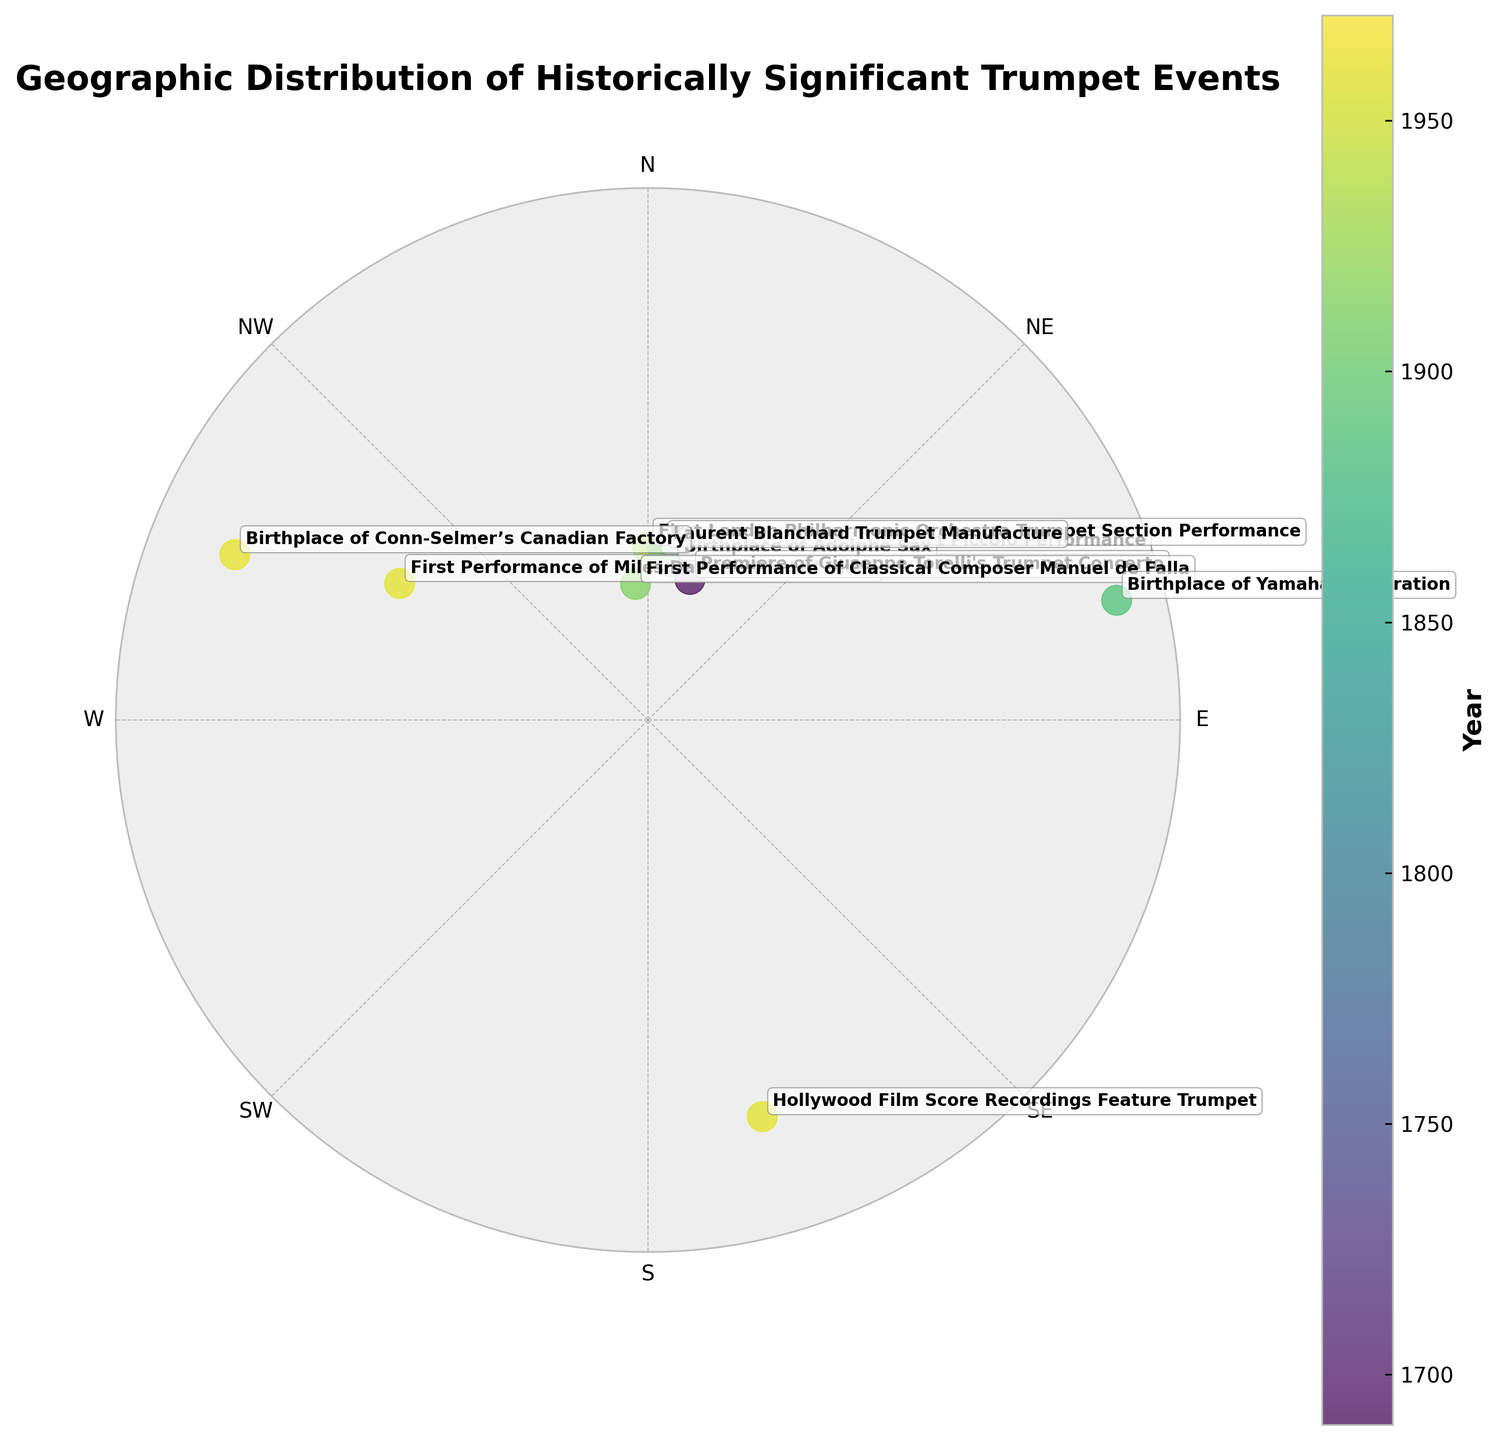what is the title of the graph? The title is located at the top of the graph and provides an overview of what the graph depicts. It reads, "Geographic Distribution of Historically Significant Trumpet Events."
Answer: Geographic Distribution of Historically Significant Trumpet Events What does the color of the scatter points represent? The color of the scatter points is based on a color bar that appears to the right of the chart and is labeled "Year," indicating that colors represent the years of the events or birthplaces.
Answer: Year How many significant data points are plotted on the graph? Each data point corresponds to an event or birthplace indicated in the graph. By counting the number of annotated points, we find there are 10 plotted data points.
Answer: 10 Which event is represented by the farthest scatter point from the center? The distance of each scatter point from the center of a polar chart corresponds to the radial component 'r'. The farthest scatter point is labeled as the "First Performance of Miles Davis's 'Kind of Blue'," occurring in the USA in 1959.
Answer: First Performance of Miles Davis's "Kind of Blue" Which quadrant contains the majority of the events? The polar scatter chart divides into quadrants based on the cardinal directions (E, NE, N, NW, W, SW,  S, SE). Most of the points cluster in the northern half of the chart, which is divided into N and NE quadrants.
Answer: Northern half (N and NE) Compare the historical distribution between the birthplace of the Conn-Selmer’s Canadian Factory and the performing event of Miles Davis's "Kind of Blue". By analyzing the color and position of the points: The birthplace of Conn-Selmer’s Canadian Factory in Canada in 1961 is closer to 1960 on the color bar, whereas Miles Davis's "Kind of Blue" performance in the USA in 1959 has a slightly earlier shade on the color bar. Both are located in the north-western part of the chart, indicating their close geographic orientation towards each other.
Answer: Similar geographical region and color range, but Davis's event is slightly earlier Which two events/birthplaces are geographically closest on the chart? Looking at the positions of the points, the "First Performance of Classical Composer Manuel de Falla" in Spain, 1913, and "First London Philharmonic Orchestra Trumpet Section Performance" in the UK, 1932, are geographically closest to each other on the chart.
Answer: Manuel de Falla Performance & London Philharmonic Trumpet Section Performance What can you infer about the distribution of trumpet events and birthplaces in Europe? Many of the points including those from Belgium, UK, Germany, Italy, and Spain are found surrounding Europe in the center-left part (NW-NE quadrant) of the polar scatter chart, indicating numerous significant trumpet events and maker birthplaces are centered around Europe.
Answer: High density of significant trumpet events and birthplaces in Europe 